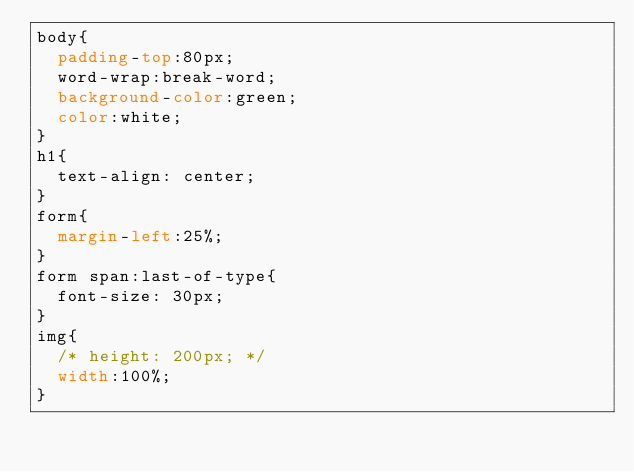Convert code to text. <code><loc_0><loc_0><loc_500><loc_500><_CSS_>body{
  padding-top:80px;
  word-wrap:break-word;
  background-color:green;
  color:white;
}
h1{
  text-align: center;
}
form{
  margin-left:25%;
}
form span:last-of-type{
  font-size: 30px;
}
img{
  /* height: 200px; */
  width:100%;
}
</code> 